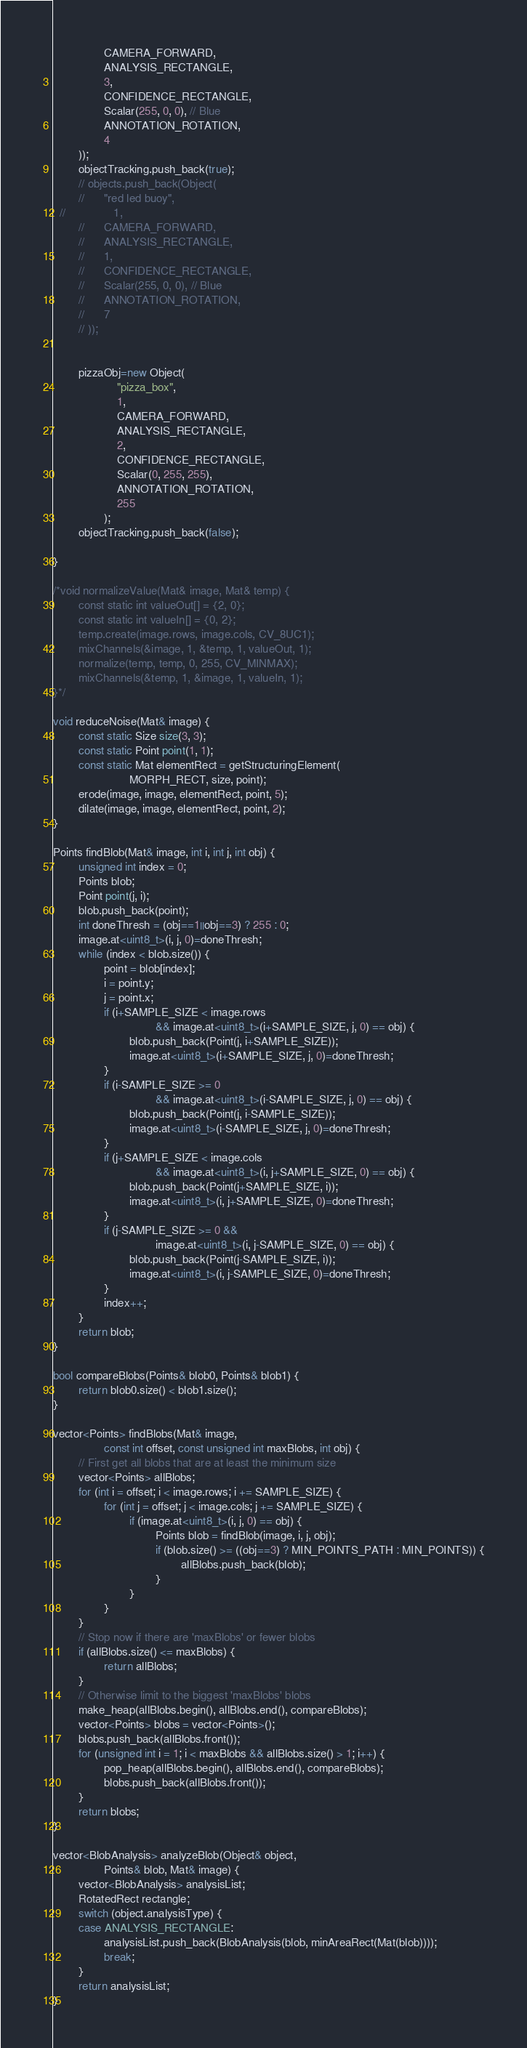<code> <loc_0><loc_0><loc_500><loc_500><_C++_>				CAMERA_FORWARD,
				ANALYSIS_RECTANGLE,
				3,
				CONFIDENCE_RECTANGLE,
				Scalar(255, 0, 0), // Blue
				ANNOTATION_ROTATION,
				4
		));
		objectTracking.push_back(true);
		// objects.push_back(Object(
		// 		"red led buoy",
  //               1,
		// 		CAMERA_FORWARD,
		// 		ANALYSIS_RECTANGLE,
		// 		1,
		// 		CONFIDENCE_RECTANGLE,
		// 		Scalar(255, 0, 0), // Blue
		// 		ANNOTATION_ROTATION,
		// 		7
		// ));


        pizzaObj=new Object(
					"pizza_box",
	                1,
					CAMERA_FORWARD,
					ANALYSIS_RECTANGLE,
					2,
					CONFIDENCE_RECTANGLE,
					Scalar(0, 255, 255),
					ANNOTATION_ROTATION,
					255
				);
        objectTracking.push_back(false);

}

/*void normalizeValue(Mat& image, Mat& temp) {
		const static int valueOut[] = {2, 0};
		const static int valueIn[] = {0, 2};
		temp.create(image.rows, image.cols, CV_8UC1);
		mixChannels(&image, 1, &temp, 1, valueOut, 1);
		normalize(temp, temp, 0, 255, CV_MINMAX);
		mixChannels(&temp, 1, &image, 1, valueIn, 1);
}*/

void reduceNoise(Mat& image) {
		const static Size size(3, 3);
		const static Point point(1, 1);
		const static Mat elementRect = getStructuringElement(
						MORPH_RECT, size, point);
		erode(image, image, elementRect, point, 5);
		dilate(image, image, elementRect, point, 2);
}

Points findBlob(Mat& image, int i, int j, int obj) {
		unsigned int index = 0;
		Points blob;
		Point point(j, i);
		blob.push_back(point);
		int doneThresh = (obj==1||obj==3) ? 255 : 0;
		image.at<uint8_t>(i, j, 0)=doneThresh;
		while (index < blob.size()) {
				point = blob[index];
				i = point.y;
				j = point.x;
				if (i+SAMPLE_SIZE < image.rows
								&& image.at<uint8_t>(i+SAMPLE_SIZE, j, 0) == obj) {
						blob.push_back(Point(j, i+SAMPLE_SIZE));
						image.at<uint8_t>(i+SAMPLE_SIZE, j, 0)=doneThresh;
				}
				if (i-SAMPLE_SIZE >= 0
								&& image.at<uint8_t>(i-SAMPLE_SIZE, j, 0) == obj) {
						blob.push_back(Point(j, i-SAMPLE_SIZE));
						image.at<uint8_t>(i-SAMPLE_SIZE, j, 0)=doneThresh;
				}
				if (j+SAMPLE_SIZE < image.cols
								&& image.at<uint8_t>(i, j+SAMPLE_SIZE, 0) == obj) {
						blob.push_back(Point(j+SAMPLE_SIZE, i));
						image.at<uint8_t>(i, j+SAMPLE_SIZE, 0)=doneThresh;
				}
				if (j-SAMPLE_SIZE >= 0 &&
								image.at<uint8_t>(i, j-SAMPLE_SIZE, 0) == obj) {
						blob.push_back(Point(j-SAMPLE_SIZE, i));
						image.at<uint8_t>(i, j-SAMPLE_SIZE, 0)=doneThresh;
				}
				index++;
		}
		return blob;
}

bool compareBlobs(Points& blob0, Points& blob1) {
		return blob0.size() < blob1.size();
}

vector<Points> findBlobs(Mat& image,
				const int offset, const unsigned int maxBlobs, int obj) {
		// First get all blobs that are at least the minimum size
		vector<Points> allBlobs;
		for (int i = offset; i < image.rows; i += SAMPLE_SIZE) {
				for (int j = offset; j < image.cols; j += SAMPLE_SIZE) {
						if (image.at<uint8_t>(i, j, 0) == obj) {
								Points blob = findBlob(image, i, j, obj);
								if (blob.size() >= ((obj==3) ? MIN_POINTS_PATH : MIN_POINTS)) {
										allBlobs.push_back(blob);
								}
						}
				}
		}
		// Stop now if there are 'maxBlobs' or fewer blobs
		if (allBlobs.size() <= maxBlobs) {
				return allBlobs;
		}
		// Otherwise limit to the biggest 'maxBlobs' blobs
		make_heap(allBlobs.begin(), allBlobs.end(), compareBlobs);
		vector<Points> blobs = vector<Points>();
		blobs.push_back(allBlobs.front());
		for (unsigned int i = 1; i < maxBlobs && allBlobs.size() > 1; i++) {
				pop_heap(allBlobs.begin(), allBlobs.end(), compareBlobs);
				blobs.push_back(allBlobs.front());
		}
		return blobs;
}

vector<BlobAnalysis> analyzeBlob(Object& object,
				Points& blob, Mat& image) {
		vector<BlobAnalysis> analysisList;
		RotatedRect rectangle;
		switch (object.analysisType) {
		case ANALYSIS_RECTANGLE:
				analysisList.push_back(BlobAnalysis(blob, minAreaRect(Mat(blob))));
				break;
		}
		return analysisList;
}
</code> 